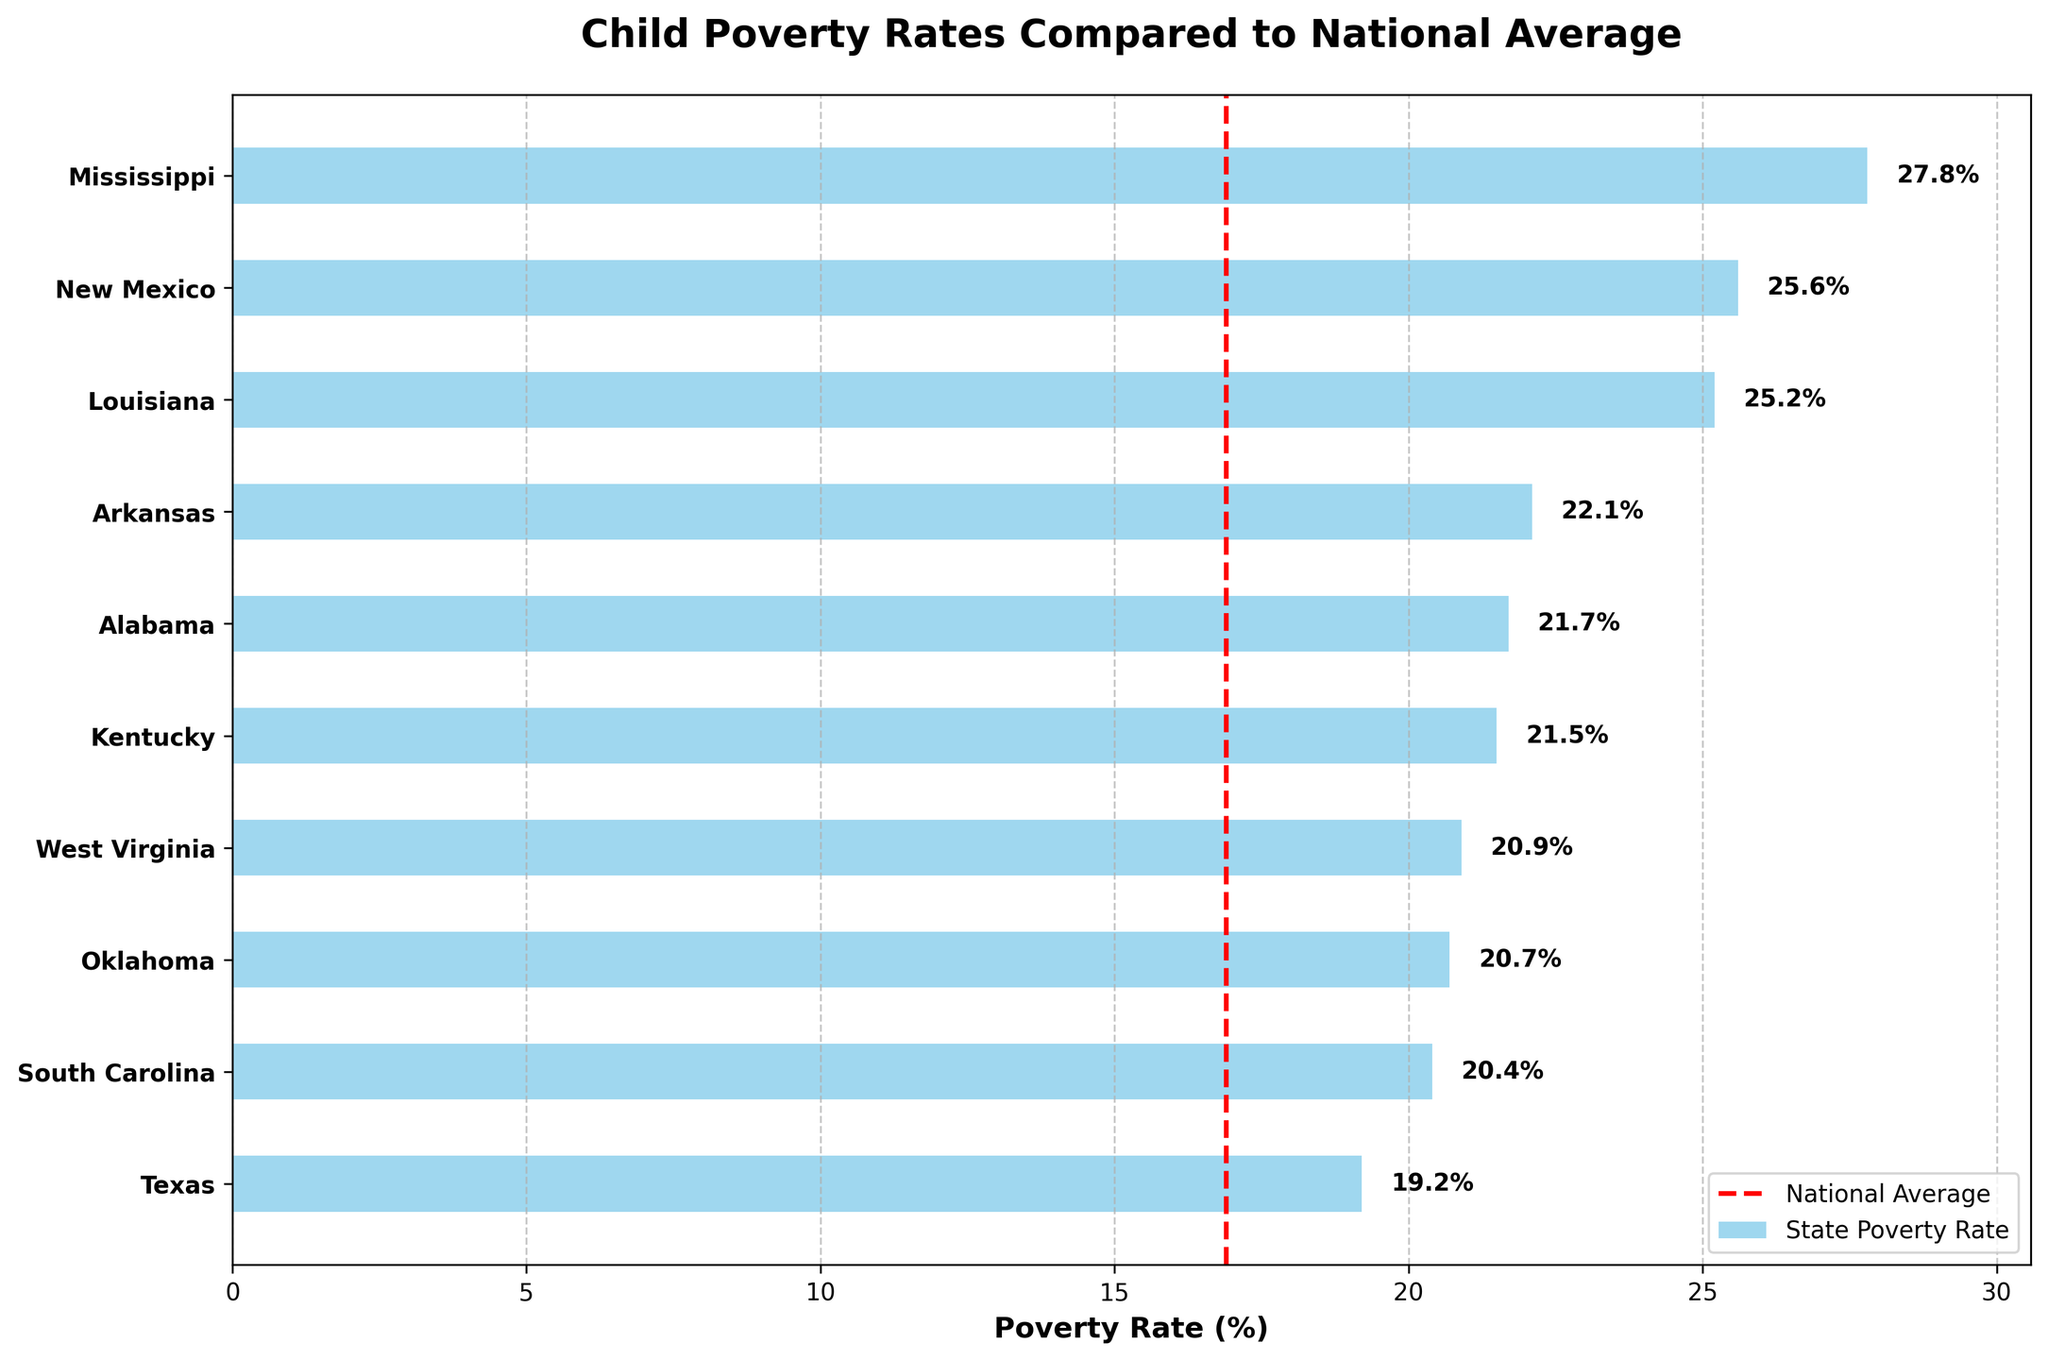what is the title of the plot? The title of the plot is written at the top of the figure. It summarizes the main topic of the visual.
Answer: Child Poverty Rates Compared to National Average Which state has the highest child poverty rate? The state with the highest child poverty rate has the longest blue bar.
Answer: Mississippi How many states have a poverty rate above the national average? Count the number of states where the blue bars extend beyond the red dashed line representing the national average.
Answer: 10 Which state has the lowest child poverty rate among the listed states? Identify the state with the shortest blue bar in the figure.
Answer: Texas By how much is Mississippi’s child poverty rate higher than the national average? Subtract the national average from Mississippi’s poverty rate.
Answer: 10.9% Which states have a poverty rate within 5 percentage points of the national average? Check the blue bars that are 5 percentage points above or below the red dashed line.
Answer: Texas How does New Mexico's child poverty rate compare to the national average? Determine if New Mexico's blue bar extends past the red dashed line and calculate the difference.
Answer: 8.7% higher Which states have a child poverty rate below 22%? Identify the states that have blue bars shorter than the 22% mark.
Answer: West Virginia, Oklahoma, South Carolina, Texas What is the range of child poverty rates in the listed states? Subtract the smallest child poverty rate from the largest child poverty rate.
Answer: 8.6% Are there more states with a child poverty rate above or below 20%? Count the number of states above 20% and below 20%.
Answer: Above 20% 